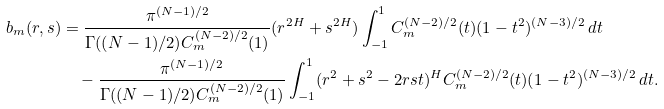Convert formula to latex. <formula><loc_0><loc_0><loc_500><loc_500>b _ { m } ( r , s ) & = \frac { \pi ^ { ( N - 1 ) / 2 } } { \Gamma ( ( N - 1 ) / 2 ) C ^ { ( N - 2 ) / 2 } _ { m } ( 1 ) } ( r ^ { 2 H } + s ^ { 2 H } ) \int ^ { 1 } _ { - 1 } C ^ { ( N - 2 ) / 2 } _ { m } ( t ) ( 1 - t ^ { 2 } ) ^ { ( N - 3 ) / 2 } \, d t \\ & \quad - \frac { \pi ^ { ( N - 1 ) / 2 } } { \Gamma ( ( N - 1 ) / 2 ) C ^ { ( N - 2 ) / 2 } _ { m } ( 1 ) } \int ^ { 1 } _ { - 1 } ( r ^ { 2 } + s ^ { 2 } - 2 r s t ) ^ { H } C ^ { ( N - 2 ) / 2 } _ { m } ( t ) ( 1 - t ^ { 2 } ) ^ { ( N - 3 ) / 2 } \, d t .</formula> 